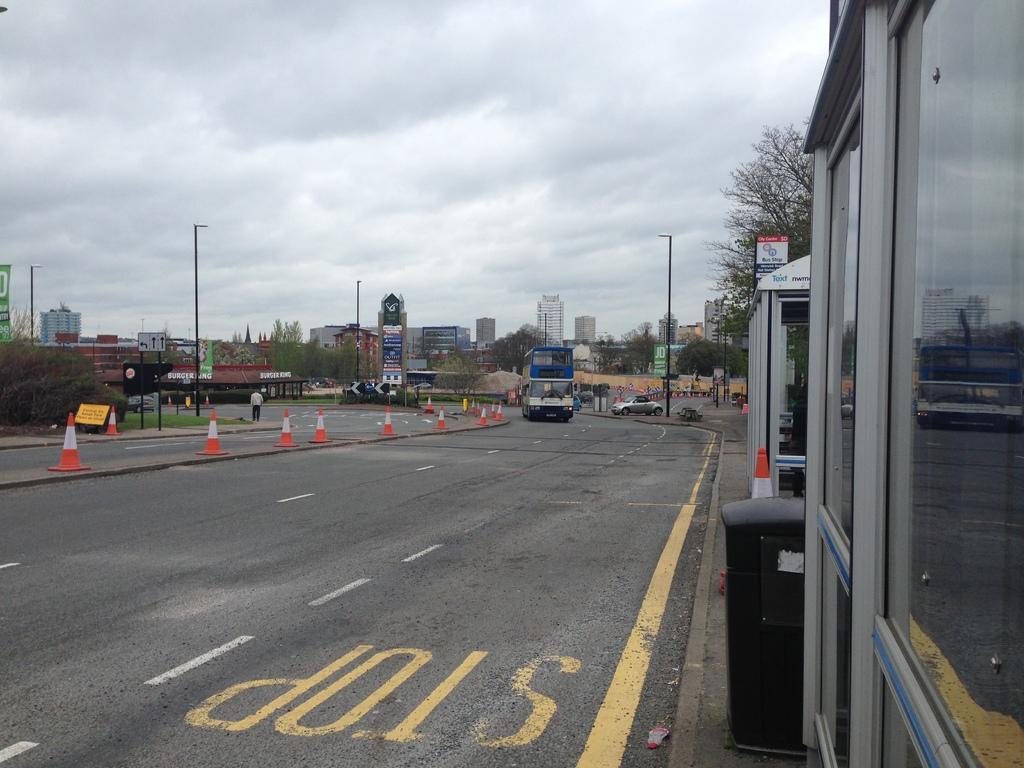How would you summarize this image in a sentence or two? In the picture we can see a road, on it we can see the bus and beside it, we can see a car near the pole and beside it, we can see a part of the tree and the building wall with glasses and opposite side, we can see some trees, poles and in the background we can see some houses, trees and the sky with clouds. 